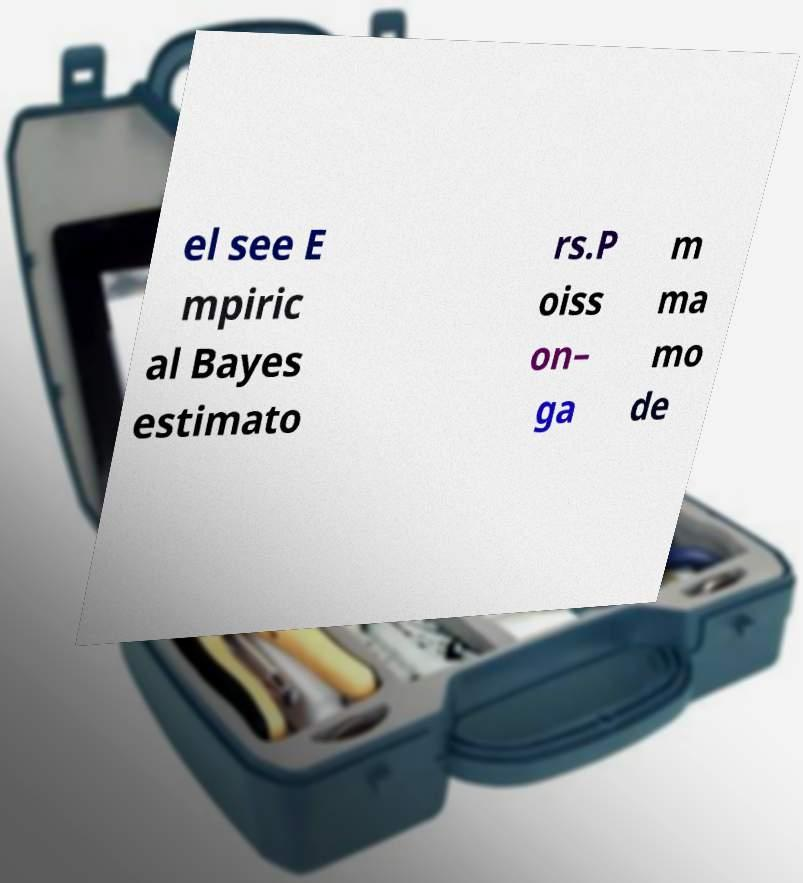Can you read and provide the text displayed in the image?This photo seems to have some interesting text. Can you extract and type it out for me? el see E mpiric al Bayes estimato rs.P oiss on– ga m ma mo de 